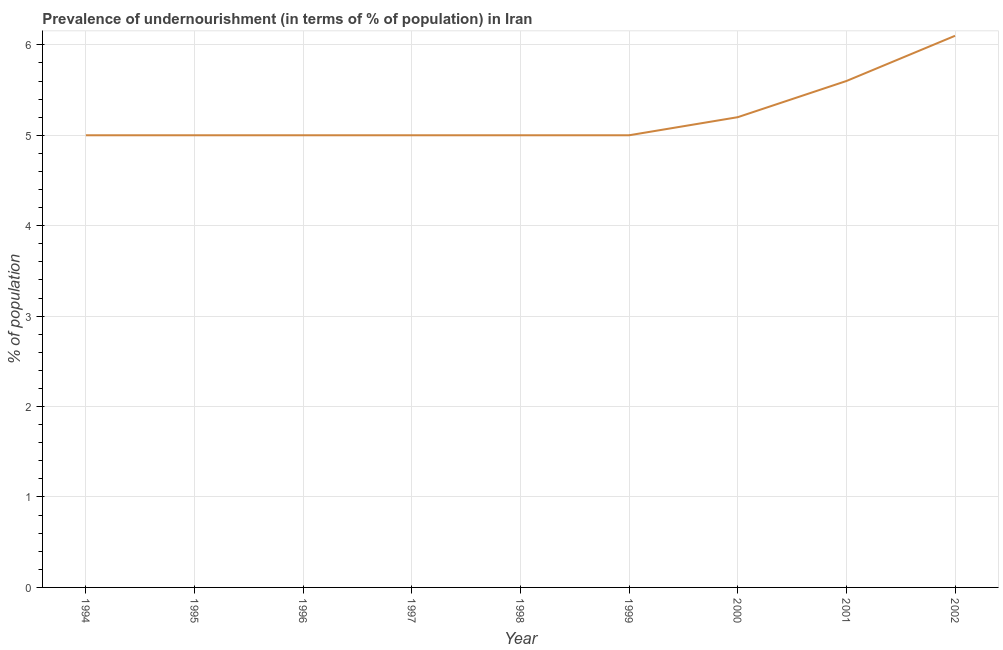What is the percentage of undernourished population in 2001?
Your response must be concise. 5.6. Across all years, what is the minimum percentage of undernourished population?
Your answer should be very brief. 5. What is the sum of the percentage of undernourished population?
Make the answer very short. 46.9. What is the difference between the percentage of undernourished population in 2000 and 2002?
Your answer should be compact. -0.9. What is the average percentage of undernourished population per year?
Make the answer very short. 5.21. What is the median percentage of undernourished population?
Your answer should be very brief. 5. What is the ratio of the percentage of undernourished population in 1995 to that in 2000?
Keep it short and to the point. 0.96. What is the difference between the highest and the second highest percentage of undernourished population?
Provide a succinct answer. 0.5. Is the sum of the percentage of undernourished population in 1995 and 1997 greater than the maximum percentage of undernourished population across all years?
Your answer should be compact. Yes. What is the difference between the highest and the lowest percentage of undernourished population?
Make the answer very short. 1.1. In how many years, is the percentage of undernourished population greater than the average percentage of undernourished population taken over all years?
Offer a terse response. 2. How many lines are there?
Give a very brief answer. 1. What is the difference between two consecutive major ticks on the Y-axis?
Offer a terse response. 1. Does the graph contain any zero values?
Your response must be concise. No. Does the graph contain grids?
Offer a terse response. Yes. What is the title of the graph?
Your answer should be very brief. Prevalence of undernourishment (in terms of % of population) in Iran. What is the label or title of the X-axis?
Provide a succinct answer. Year. What is the label or title of the Y-axis?
Provide a succinct answer. % of population. What is the % of population of 1995?
Your response must be concise. 5. What is the % of population of 1998?
Make the answer very short. 5. What is the % of population in 2001?
Ensure brevity in your answer.  5.6. What is the % of population in 2002?
Offer a terse response. 6.1. What is the difference between the % of population in 1994 and 1995?
Provide a short and direct response. 0. What is the difference between the % of population in 1994 and 1999?
Ensure brevity in your answer.  0. What is the difference between the % of population in 1995 and 1996?
Keep it short and to the point. 0. What is the difference between the % of population in 1995 and 1998?
Keep it short and to the point. 0. What is the difference between the % of population in 1995 and 1999?
Give a very brief answer. 0. What is the difference between the % of population in 1995 and 2000?
Your answer should be compact. -0.2. What is the difference between the % of population in 1995 and 2002?
Offer a very short reply. -1.1. What is the difference between the % of population in 1997 and 1998?
Your answer should be very brief. 0. What is the difference between the % of population in 1997 and 1999?
Your response must be concise. 0. What is the difference between the % of population in 1997 and 2000?
Keep it short and to the point. -0.2. What is the difference between the % of population in 1997 and 2001?
Your answer should be very brief. -0.6. What is the difference between the % of population in 1997 and 2002?
Your response must be concise. -1.1. What is the difference between the % of population in 1998 and 1999?
Keep it short and to the point. 0. What is the difference between the % of population in 1998 and 2000?
Make the answer very short. -0.2. What is the difference between the % of population in 1999 and 2001?
Give a very brief answer. -0.6. What is the difference between the % of population in 1999 and 2002?
Provide a succinct answer. -1.1. What is the difference between the % of population in 2000 and 2001?
Give a very brief answer. -0.4. What is the difference between the % of population in 2001 and 2002?
Your response must be concise. -0.5. What is the ratio of the % of population in 1994 to that in 1995?
Make the answer very short. 1. What is the ratio of the % of population in 1994 to that in 1996?
Your answer should be compact. 1. What is the ratio of the % of population in 1994 to that in 1997?
Make the answer very short. 1. What is the ratio of the % of population in 1994 to that in 1998?
Your answer should be very brief. 1. What is the ratio of the % of population in 1994 to that in 2001?
Provide a succinct answer. 0.89. What is the ratio of the % of population in 1994 to that in 2002?
Make the answer very short. 0.82. What is the ratio of the % of population in 1995 to that in 2001?
Ensure brevity in your answer.  0.89. What is the ratio of the % of population in 1995 to that in 2002?
Offer a very short reply. 0.82. What is the ratio of the % of population in 1996 to that in 1997?
Your answer should be very brief. 1. What is the ratio of the % of population in 1996 to that in 1998?
Provide a short and direct response. 1. What is the ratio of the % of population in 1996 to that in 2000?
Your answer should be compact. 0.96. What is the ratio of the % of population in 1996 to that in 2001?
Give a very brief answer. 0.89. What is the ratio of the % of population in 1996 to that in 2002?
Offer a terse response. 0.82. What is the ratio of the % of population in 1997 to that in 1999?
Your response must be concise. 1. What is the ratio of the % of population in 1997 to that in 2001?
Ensure brevity in your answer.  0.89. What is the ratio of the % of population in 1997 to that in 2002?
Your answer should be compact. 0.82. What is the ratio of the % of population in 1998 to that in 2000?
Provide a succinct answer. 0.96. What is the ratio of the % of population in 1998 to that in 2001?
Your answer should be very brief. 0.89. What is the ratio of the % of population in 1998 to that in 2002?
Keep it short and to the point. 0.82. What is the ratio of the % of population in 1999 to that in 2001?
Ensure brevity in your answer.  0.89. What is the ratio of the % of population in 1999 to that in 2002?
Make the answer very short. 0.82. What is the ratio of the % of population in 2000 to that in 2001?
Make the answer very short. 0.93. What is the ratio of the % of population in 2000 to that in 2002?
Give a very brief answer. 0.85. What is the ratio of the % of population in 2001 to that in 2002?
Provide a short and direct response. 0.92. 